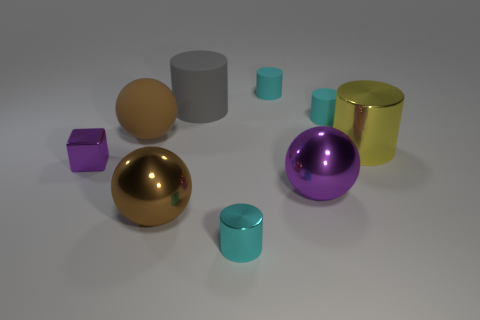Subtract all large metallic spheres. How many spheres are left? 1 Add 1 matte things. How many objects exist? 10 Subtract all gray cylinders. How many cylinders are left? 4 Subtract all cylinders. How many objects are left? 4 Subtract 1 cylinders. How many cylinders are left? 4 Subtract all purple metallic cubes. Subtract all gray matte cylinders. How many objects are left? 7 Add 5 cyan matte cylinders. How many cyan matte cylinders are left? 7 Add 8 yellow spheres. How many yellow spheres exist? 8 Subtract 0 purple cylinders. How many objects are left? 9 Subtract all yellow cylinders. Subtract all brown spheres. How many cylinders are left? 4 